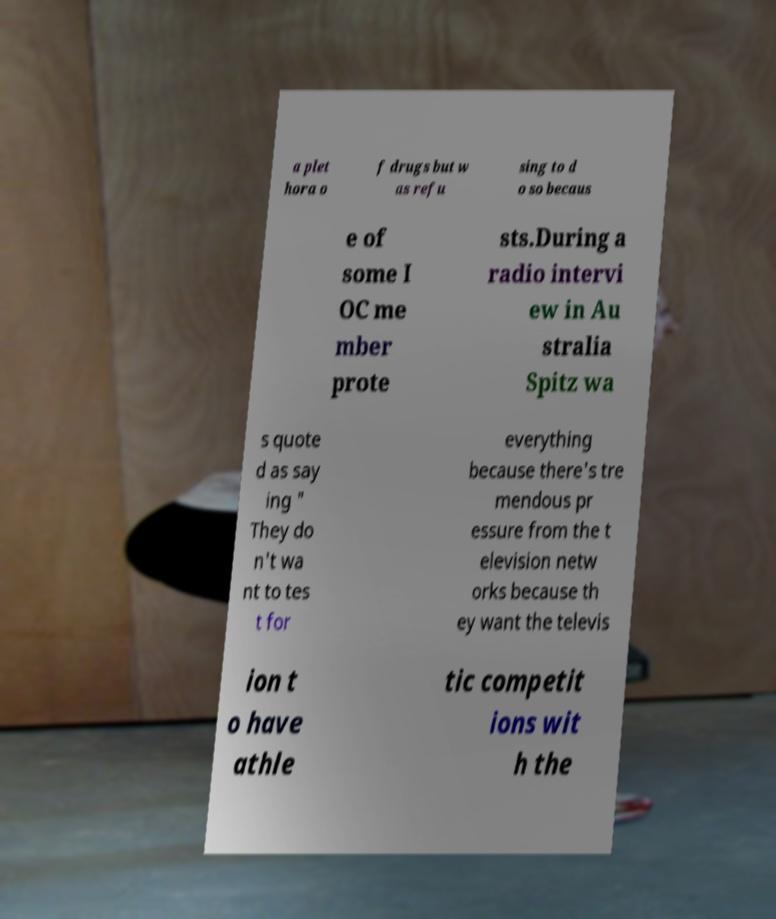For documentation purposes, I need the text within this image transcribed. Could you provide that? a plet hora o f drugs but w as refu sing to d o so becaus e of some I OC me mber prote sts.During a radio intervi ew in Au stralia Spitz wa s quote d as say ing " They do n't wa nt to tes t for everything because there's tre mendous pr essure from the t elevision netw orks because th ey want the televis ion t o have athle tic competit ions wit h the 